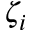Convert formula to latex. <formula><loc_0><loc_0><loc_500><loc_500>\zeta _ { i }</formula> 